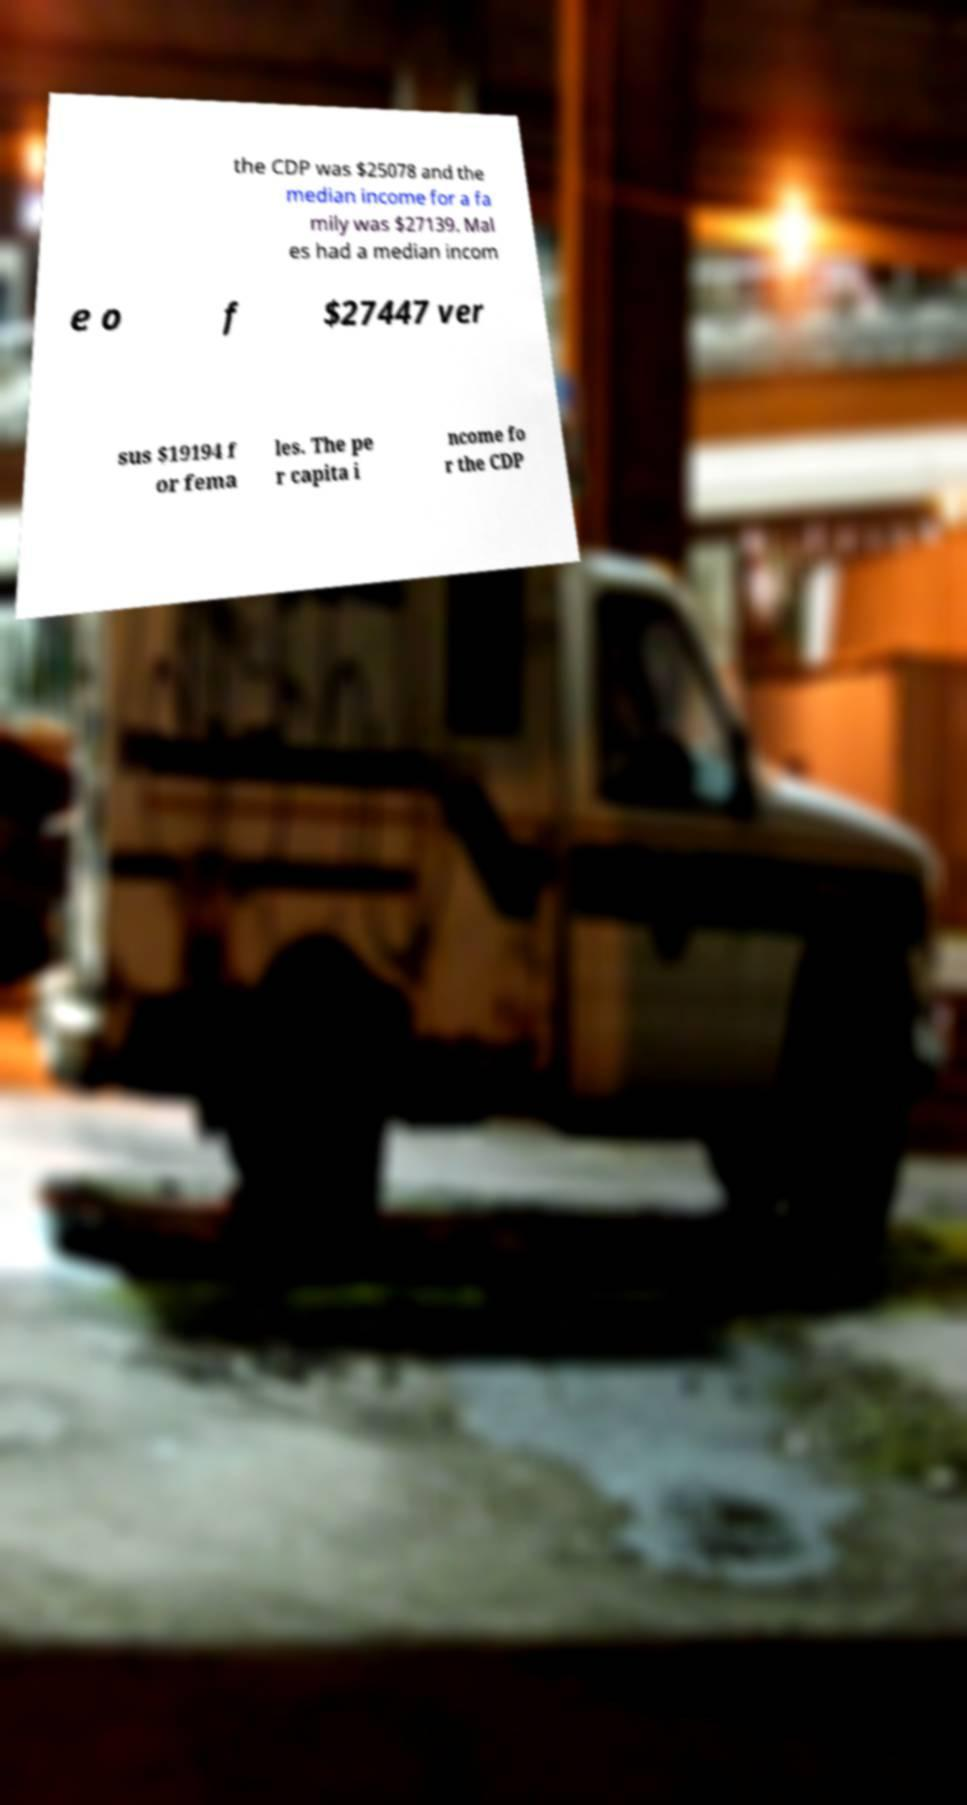Could you extract and type out the text from this image? the CDP was $25078 and the median income for a fa mily was $27139. Mal es had a median incom e o f $27447 ver sus $19194 f or fema les. The pe r capita i ncome fo r the CDP 